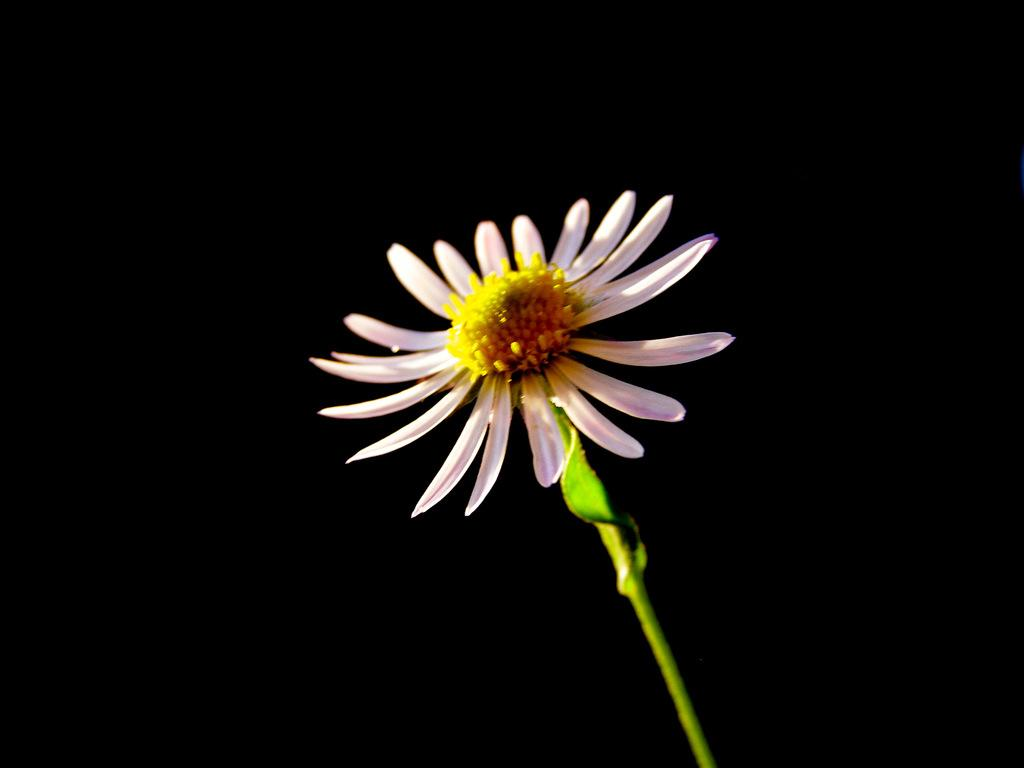What is the main subject of the picture? The main subject of the picture is a flower. Can you describe the flower's structure? The flower has a stem. What color are the petals of the flower? The petals of the flower are light pink in color. What type of liquid can be seen flowing from the flower in the image? There is no liquid flowing from the flower in the image; it is a static image of a flower with light pink petals. Are there any toys visible in the image? No, there are no toys present in the image; it only features a flower with a stem and light pink petals. 